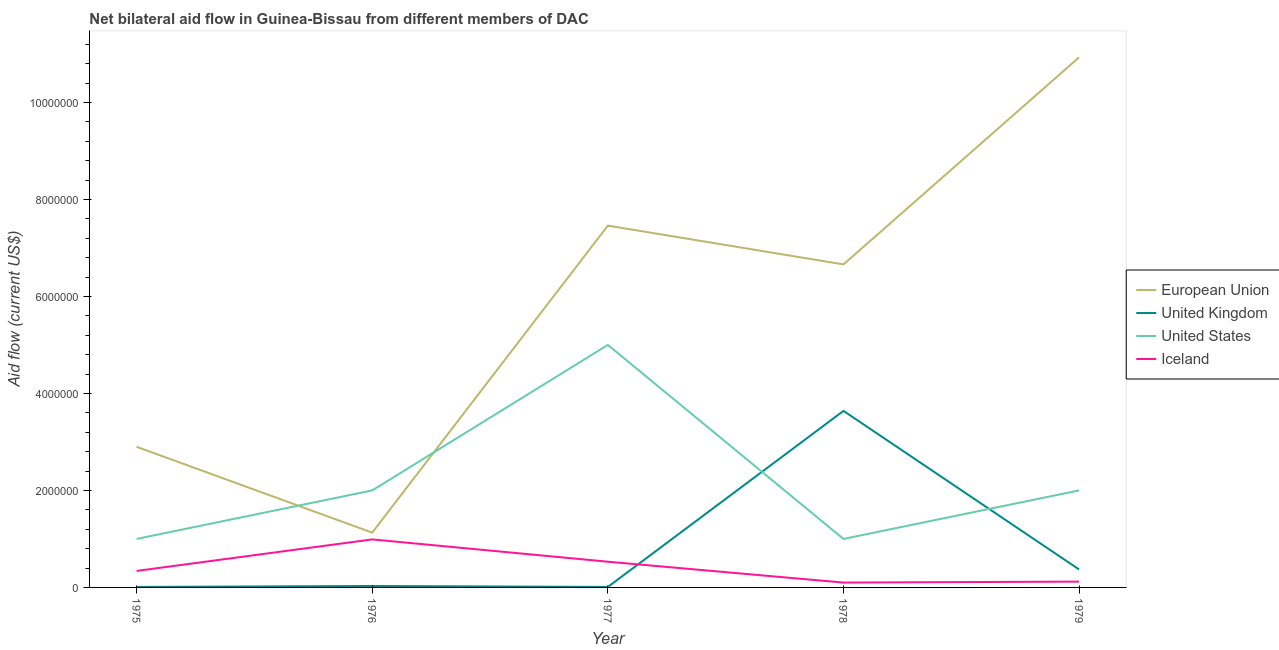Does the line corresponding to amount of aid given by eu intersect with the line corresponding to amount of aid given by uk?
Provide a short and direct response. No. What is the amount of aid given by eu in 1977?
Provide a succinct answer. 7.46e+06. Across all years, what is the maximum amount of aid given by iceland?
Make the answer very short. 9.90e+05. Across all years, what is the minimum amount of aid given by uk?
Offer a very short reply. 10000. In which year was the amount of aid given by us maximum?
Your answer should be very brief. 1977. In which year was the amount of aid given by iceland minimum?
Your answer should be very brief. 1978. What is the total amount of aid given by us in the graph?
Give a very brief answer. 1.10e+07. What is the difference between the amount of aid given by uk in 1975 and that in 1977?
Give a very brief answer. 0. What is the difference between the amount of aid given by iceland in 1979 and the amount of aid given by us in 1976?
Your answer should be very brief. -1.88e+06. What is the average amount of aid given by us per year?
Your answer should be compact. 2.20e+06. In the year 1977, what is the difference between the amount of aid given by eu and amount of aid given by iceland?
Keep it short and to the point. 6.93e+06. In how many years, is the amount of aid given by us greater than 10000000 US$?
Make the answer very short. 0. Is the difference between the amount of aid given by us in 1976 and 1978 greater than the difference between the amount of aid given by iceland in 1976 and 1978?
Your answer should be compact. Yes. What is the difference between the highest and the second highest amount of aid given by us?
Your response must be concise. 3.00e+06. What is the difference between the highest and the lowest amount of aid given by eu?
Provide a short and direct response. 9.80e+06. In how many years, is the amount of aid given by iceland greater than the average amount of aid given by iceland taken over all years?
Your response must be concise. 2. Is it the case that in every year, the sum of the amount of aid given by eu and amount of aid given by uk is greater than the amount of aid given by us?
Ensure brevity in your answer.  No. Does the amount of aid given by uk monotonically increase over the years?
Keep it short and to the point. No. Is the amount of aid given by uk strictly less than the amount of aid given by eu over the years?
Keep it short and to the point. Yes. How many lines are there?
Provide a succinct answer. 4. How many years are there in the graph?
Provide a short and direct response. 5. Are the values on the major ticks of Y-axis written in scientific E-notation?
Your response must be concise. No. Does the graph contain any zero values?
Ensure brevity in your answer.  No. What is the title of the graph?
Provide a short and direct response. Net bilateral aid flow in Guinea-Bissau from different members of DAC. What is the Aid flow (current US$) of European Union in 1975?
Make the answer very short. 2.90e+06. What is the Aid flow (current US$) in Iceland in 1975?
Ensure brevity in your answer.  3.40e+05. What is the Aid flow (current US$) of European Union in 1976?
Ensure brevity in your answer.  1.13e+06. What is the Aid flow (current US$) in United Kingdom in 1976?
Give a very brief answer. 3.00e+04. What is the Aid flow (current US$) in United States in 1976?
Your answer should be compact. 2.00e+06. What is the Aid flow (current US$) in Iceland in 1976?
Your response must be concise. 9.90e+05. What is the Aid flow (current US$) of European Union in 1977?
Your answer should be very brief. 7.46e+06. What is the Aid flow (current US$) of United Kingdom in 1977?
Provide a succinct answer. 10000. What is the Aid flow (current US$) of United States in 1977?
Ensure brevity in your answer.  5.00e+06. What is the Aid flow (current US$) of Iceland in 1977?
Provide a succinct answer. 5.30e+05. What is the Aid flow (current US$) in European Union in 1978?
Your response must be concise. 6.66e+06. What is the Aid flow (current US$) in United Kingdom in 1978?
Offer a very short reply. 3.64e+06. What is the Aid flow (current US$) in Iceland in 1978?
Make the answer very short. 1.00e+05. What is the Aid flow (current US$) in European Union in 1979?
Offer a very short reply. 1.09e+07. What is the Aid flow (current US$) of United Kingdom in 1979?
Give a very brief answer. 3.70e+05. Across all years, what is the maximum Aid flow (current US$) in European Union?
Your answer should be very brief. 1.09e+07. Across all years, what is the maximum Aid flow (current US$) of United Kingdom?
Offer a terse response. 3.64e+06. Across all years, what is the maximum Aid flow (current US$) of United States?
Your answer should be compact. 5.00e+06. Across all years, what is the maximum Aid flow (current US$) of Iceland?
Make the answer very short. 9.90e+05. Across all years, what is the minimum Aid flow (current US$) in European Union?
Your answer should be compact. 1.13e+06. What is the total Aid flow (current US$) in European Union in the graph?
Ensure brevity in your answer.  2.91e+07. What is the total Aid flow (current US$) in United Kingdom in the graph?
Offer a very short reply. 4.06e+06. What is the total Aid flow (current US$) of United States in the graph?
Give a very brief answer. 1.10e+07. What is the total Aid flow (current US$) of Iceland in the graph?
Keep it short and to the point. 2.08e+06. What is the difference between the Aid flow (current US$) in European Union in 1975 and that in 1976?
Offer a terse response. 1.77e+06. What is the difference between the Aid flow (current US$) in United States in 1975 and that in 1976?
Make the answer very short. -1.00e+06. What is the difference between the Aid flow (current US$) of Iceland in 1975 and that in 1976?
Provide a short and direct response. -6.50e+05. What is the difference between the Aid flow (current US$) in European Union in 1975 and that in 1977?
Ensure brevity in your answer.  -4.56e+06. What is the difference between the Aid flow (current US$) in United Kingdom in 1975 and that in 1977?
Your answer should be very brief. 0. What is the difference between the Aid flow (current US$) of United States in 1975 and that in 1977?
Provide a short and direct response. -4.00e+06. What is the difference between the Aid flow (current US$) of Iceland in 1975 and that in 1977?
Offer a terse response. -1.90e+05. What is the difference between the Aid flow (current US$) in European Union in 1975 and that in 1978?
Your answer should be very brief. -3.76e+06. What is the difference between the Aid flow (current US$) in United Kingdom in 1975 and that in 1978?
Your response must be concise. -3.63e+06. What is the difference between the Aid flow (current US$) in United States in 1975 and that in 1978?
Ensure brevity in your answer.  0. What is the difference between the Aid flow (current US$) in Iceland in 1975 and that in 1978?
Give a very brief answer. 2.40e+05. What is the difference between the Aid flow (current US$) in European Union in 1975 and that in 1979?
Keep it short and to the point. -8.03e+06. What is the difference between the Aid flow (current US$) in United Kingdom in 1975 and that in 1979?
Offer a very short reply. -3.60e+05. What is the difference between the Aid flow (current US$) in United States in 1975 and that in 1979?
Provide a succinct answer. -1.00e+06. What is the difference between the Aid flow (current US$) of Iceland in 1975 and that in 1979?
Your answer should be compact. 2.20e+05. What is the difference between the Aid flow (current US$) in European Union in 1976 and that in 1977?
Your answer should be compact. -6.33e+06. What is the difference between the Aid flow (current US$) of European Union in 1976 and that in 1978?
Offer a terse response. -5.53e+06. What is the difference between the Aid flow (current US$) in United Kingdom in 1976 and that in 1978?
Ensure brevity in your answer.  -3.61e+06. What is the difference between the Aid flow (current US$) in Iceland in 1976 and that in 1978?
Keep it short and to the point. 8.90e+05. What is the difference between the Aid flow (current US$) in European Union in 1976 and that in 1979?
Your answer should be compact. -9.80e+06. What is the difference between the Aid flow (current US$) in United States in 1976 and that in 1979?
Your response must be concise. 0. What is the difference between the Aid flow (current US$) of Iceland in 1976 and that in 1979?
Offer a terse response. 8.70e+05. What is the difference between the Aid flow (current US$) of European Union in 1977 and that in 1978?
Keep it short and to the point. 8.00e+05. What is the difference between the Aid flow (current US$) of United Kingdom in 1977 and that in 1978?
Make the answer very short. -3.63e+06. What is the difference between the Aid flow (current US$) of United States in 1977 and that in 1978?
Your response must be concise. 4.00e+06. What is the difference between the Aid flow (current US$) of European Union in 1977 and that in 1979?
Offer a terse response. -3.47e+06. What is the difference between the Aid flow (current US$) in United Kingdom in 1977 and that in 1979?
Your answer should be compact. -3.60e+05. What is the difference between the Aid flow (current US$) of United States in 1977 and that in 1979?
Keep it short and to the point. 3.00e+06. What is the difference between the Aid flow (current US$) of Iceland in 1977 and that in 1979?
Offer a terse response. 4.10e+05. What is the difference between the Aid flow (current US$) in European Union in 1978 and that in 1979?
Provide a short and direct response. -4.27e+06. What is the difference between the Aid flow (current US$) in United Kingdom in 1978 and that in 1979?
Provide a short and direct response. 3.27e+06. What is the difference between the Aid flow (current US$) of United States in 1978 and that in 1979?
Your answer should be very brief. -1.00e+06. What is the difference between the Aid flow (current US$) in Iceland in 1978 and that in 1979?
Your answer should be compact. -2.00e+04. What is the difference between the Aid flow (current US$) in European Union in 1975 and the Aid flow (current US$) in United Kingdom in 1976?
Offer a terse response. 2.87e+06. What is the difference between the Aid flow (current US$) of European Union in 1975 and the Aid flow (current US$) of Iceland in 1976?
Keep it short and to the point. 1.91e+06. What is the difference between the Aid flow (current US$) in United Kingdom in 1975 and the Aid flow (current US$) in United States in 1976?
Provide a short and direct response. -1.99e+06. What is the difference between the Aid flow (current US$) in United Kingdom in 1975 and the Aid flow (current US$) in Iceland in 1976?
Provide a short and direct response. -9.80e+05. What is the difference between the Aid flow (current US$) in European Union in 1975 and the Aid flow (current US$) in United Kingdom in 1977?
Make the answer very short. 2.89e+06. What is the difference between the Aid flow (current US$) of European Union in 1975 and the Aid flow (current US$) of United States in 1977?
Give a very brief answer. -2.10e+06. What is the difference between the Aid flow (current US$) in European Union in 1975 and the Aid flow (current US$) in Iceland in 1977?
Keep it short and to the point. 2.37e+06. What is the difference between the Aid flow (current US$) of United Kingdom in 1975 and the Aid flow (current US$) of United States in 1977?
Ensure brevity in your answer.  -4.99e+06. What is the difference between the Aid flow (current US$) in United Kingdom in 1975 and the Aid flow (current US$) in Iceland in 1977?
Provide a short and direct response. -5.20e+05. What is the difference between the Aid flow (current US$) of European Union in 1975 and the Aid flow (current US$) of United Kingdom in 1978?
Ensure brevity in your answer.  -7.40e+05. What is the difference between the Aid flow (current US$) in European Union in 1975 and the Aid flow (current US$) in United States in 1978?
Offer a very short reply. 1.90e+06. What is the difference between the Aid flow (current US$) in European Union in 1975 and the Aid flow (current US$) in Iceland in 1978?
Provide a short and direct response. 2.80e+06. What is the difference between the Aid flow (current US$) in United Kingdom in 1975 and the Aid flow (current US$) in United States in 1978?
Ensure brevity in your answer.  -9.90e+05. What is the difference between the Aid flow (current US$) in United States in 1975 and the Aid flow (current US$) in Iceland in 1978?
Provide a succinct answer. 9.00e+05. What is the difference between the Aid flow (current US$) in European Union in 1975 and the Aid flow (current US$) in United Kingdom in 1979?
Offer a terse response. 2.53e+06. What is the difference between the Aid flow (current US$) in European Union in 1975 and the Aid flow (current US$) in Iceland in 1979?
Provide a succinct answer. 2.78e+06. What is the difference between the Aid flow (current US$) of United Kingdom in 1975 and the Aid flow (current US$) of United States in 1979?
Provide a short and direct response. -1.99e+06. What is the difference between the Aid flow (current US$) in United Kingdom in 1975 and the Aid flow (current US$) in Iceland in 1979?
Give a very brief answer. -1.10e+05. What is the difference between the Aid flow (current US$) of United States in 1975 and the Aid flow (current US$) of Iceland in 1979?
Your answer should be very brief. 8.80e+05. What is the difference between the Aid flow (current US$) of European Union in 1976 and the Aid flow (current US$) of United Kingdom in 1977?
Make the answer very short. 1.12e+06. What is the difference between the Aid flow (current US$) in European Union in 1976 and the Aid flow (current US$) in United States in 1977?
Ensure brevity in your answer.  -3.87e+06. What is the difference between the Aid flow (current US$) of United Kingdom in 1976 and the Aid flow (current US$) of United States in 1977?
Provide a short and direct response. -4.97e+06. What is the difference between the Aid flow (current US$) of United Kingdom in 1976 and the Aid flow (current US$) of Iceland in 1977?
Provide a short and direct response. -5.00e+05. What is the difference between the Aid flow (current US$) of United States in 1976 and the Aid flow (current US$) of Iceland in 1977?
Keep it short and to the point. 1.47e+06. What is the difference between the Aid flow (current US$) of European Union in 1976 and the Aid flow (current US$) of United Kingdom in 1978?
Offer a very short reply. -2.51e+06. What is the difference between the Aid flow (current US$) of European Union in 1976 and the Aid flow (current US$) of United States in 1978?
Ensure brevity in your answer.  1.30e+05. What is the difference between the Aid flow (current US$) in European Union in 1976 and the Aid flow (current US$) in Iceland in 1978?
Offer a terse response. 1.03e+06. What is the difference between the Aid flow (current US$) of United Kingdom in 1976 and the Aid flow (current US$) of United States in 1978?
Your response must be concise. -9.70e+05. What is the difference between the Aid flow (current US$) in United Kingdom in 1976 and the Aid flow (current US$) in Iceland in 1978?
Ensure brevity in your answer.  -7.00e+04. What is the difference between the Aid flow (current US$) in United States in 1976 and the Aid flow (current US$) in Iceland in 1978?
Offer a very short reply. 1.90e+06. What is the difference between the Aid flow (current US$) in European Union in 1976 and the Aid flow (current US$) in United Kingdom in 1979?
Offer a terse response. 7.60e+05. What is the difference between the Aid flow (current US$) of European Union in 1976 and the Aid flow (current US$) of United States in 1979?
Your answer should be very brief. -8.70e+05. What is the difference between the Aid flow (current US$) of European Union in 1976 and the Aid flow (current US$) of Iceland in 1979?
Give a very brief answer. 1.01e+06. What is the difference between the Aid flow (current US$) in United Kingdom in 1976 and the Aid flow (current US$) in United States in 1979?
Provide a short and direct response. -1.97e+06. What is the difference between the Aid flow (current US$) in United Kingdom in 1976 and the Aid flow (current US$) in Iceland in 1979?
Offer a very short reply. -9.00e+04. What is the difference between the Aid flow (current US$) of United States in 1976 and the Aid flow (current US$) of Iceland in 1979?
Provide a short and direct response. 1.88e+06. What is the difference between the Aid flow (current US$) of European Union in 1977 and the Aid flow (current US$) of United Kingdom in 1978?
Provide a succinct answer. 3.82e+06. What is the difference between the Aid flow (current US$) in European Union in 1977 and the Aid flow (current US$) in United States in 1978?
Provide a succinct answer. 6.46e+06. What is the difference between the Aid flow (current US$) of European Union in 1977 and the Aid flow (current US$) of Iceland in 1978?
Offer a terse response. 7.36e+06. What is the difference between the Aid flow (current US$) of United Kingdom in 1977 and the Aid flow (current US$) of United States in 1978?
Keep it short and to the point. -9.90e+05. What is the difference between the Aid flow (current US$) in United States in 1977 and the Aid flow (current US$) in Iceland in 1978?
Provide a short and direct response. 4.90e+06. What is the difference between the Aid flow (current US$) of European Union in 1977 and the Aid flow (current US$) of United Kingdom in 1979?
Your answer should be compact. 7.09e+06. What is the difference between the Aid flow (current US$) in European Union in 1977 and the Aid flow (current US$) in United States in 1979?
Make the answer very short. 5.46e+06. What is the difference between the Aid flow (current US$) of European Union in 1977 and the Aid flow (current US$) of Iceland in 1979?
Give a very brief answer. 7.34e+06. What is the difference between the Aid flow (current US$) in United Kingdom in 1977 and the Aid flow (current US$) in United States in 1979?
Provide a short and direct response. -1.99e+06. What is the difference between the Aid flow (current US$) in United Kingdom in 1977 and the Aid flow (current US$) in Iceland in 1979?
Provide a short and direct response. -1.10e+05. What is the difference between the Aid flow (current US$) in United States in 1977 and the Aid flow (current US$) in Iceland in 1979?
Keep it short and to the point. 4.88e+06. What is the difference between the Aid flow (current US$) of European Union in 1978 and the Aid flow (current US$) of United Kingdom in 1979?
Ensure brevity in your answer.  6.29e+06. What is the difference between the Aid flow (current US$) of European Union in 1978 and the Aid flow (current US$) of United States in 1979?
Your answer should be compact. 4.66e+06. What is the difference between the Aid flow (current US$) in European Union in 1978 and the Aid flow (current US$) in Iceland in 1979?
Ensure brevity in your answer.  6.54e+06. What is the difference between the Aid flow (current US$) of United Kingdom in 1978 and the Aid flow (current US$) of United States in 1979?
Your answer should be compact. 1.64e+06. What is the difference between the Aid flow (current US$) in United Kingdom in 1978 and the Aid flow (current US$) in Iceland in 1979?
Your answer should be compact. 3.52e+06. What is the difference between the Aid flow (current US$) in United States in 1978 and the Aid flow (current US$) in Iceland in 1979?
Provide a short and direct response. 8.80e+05. What is the average Aid flow (current US$) in European Union per year?
Give a very brief answer. 5.82e+06. What is the average Aid flow (current US$) in United Kingdom per year?
Give a very brief answer. 8.12e+05. What is the average Aid flow (current US$) of United States per year?
Offer a terse response. 2.20e+06. What is the average Aid flow (current US$) in Iceland per year?
Give a very brief answer. 4.16e+05. In the year 1975, what is the difference between the Aid flow (current US$) in European Union and Aid flow (current US$) in United Kingdom?
Offer a very short reply. 2.89e+06. In the year 1975, what is the difference between the Aid flow (current US$) of European Union and Aid flow (current US$) of United States?
Offer a terse response. 1.90e+06. In the year 1975, what is the difference between the Aid flow (current US$) of European Union and Aid flow (current US$) of Iceland?
Keep it short and to the point. 2.56e+06. In the year 1975, what is the difference between the Aid flow (current US$) of United Kingdom and Aid flow (current US$) of United States?
Provide a succinct answer. -9.90e+05. In the year 1975, what is the difference between the Aid flow (current US$) in United Kingdom and Aid flow (current US$) in Iceland?
Give a very brief answer. -3.30e+05. In the year 1975, what is the difference between the Aid flow (current US$) in United States and Aid flow (current US$) in Iceland?
Your response must be concise. 6.60e+05. In the year 1976, what is the difference between the Aid flow (current US$) of European Union and Aid flow (current US$) of United Kingdom?
Your response must be concise. 1.10e+06. In the year 1976, what is the difference between the Aid flow (current US$) in European Union and Aid flow (current US$) in United States?
Make the answer very short. -8.70e+05. In the year 1976, what is the difference between the Aid flow (current US$) in United Kingdom and Aid flow (current US$) in United States?
Your response must be concise. -1.97e+06. In the year 1976, what is the difference between the Aid flow (current US$) in United Kingdom and Aid flow (current US$) in Iceland?
Keep it short and to the point. -9.60e+05. In the year 1976, what is the difference between the Aid flow (current US$) in United States and Aid flow (current US$) in Iceland?
Provide a short and direct response. 1.01e+06. In the year 1977, what is the difference between the Aid flow (current US$) in European Union and Aid flow (current US$) in United Kingdom?
Your answer should be very brief. 7.45e+06. In the year 1977, what is the difference between the Aid flow (current US$) of European Union and Aid flow (current US$) of United States?
Ensure brevity in your answer.  2.46e+06. In the year 1977, what is the difference between the Aid flow (current US$) of European Union and Aid flow (current US$) of Iceland?
Your answer should be very brief. 6.93e+06. In the year 1977, what is the difference between the Aid flow (current US$) in United Kingdom and Aid flow (current US$) in United States?
Ensure brevity in your answer.  -4.99e+06. In the year 1977, what is the difference between the Aid flow (current US$) of United Kingdom and Aid flow (current US$) of Iceland?
Offer a terse response. -5.20e+05. In the year 1977, what is the difference between the Aid flow (current US$) of United States and Aid flow (current US$) of Iceland?
Ensure brevity in your answer.  4.47e+06. In the year 1978, what is the difference between the Aid flow (current US$) of European Union and Aid flow (current US$) of United Kingdom?
Give a very brief answer. 3.02e+06. In the year 1978, what is the difference between the Aid flow (current US$) in European Union and Aid flow (current US$) in United States?
Offer a terse response. 5.66e+06. In the year 1978, what is the difference between the Aid flow (current US$) of European Union and Aid flow (current US$) of Iceland?
Your answer should be very brief. 6.56e+06. In the year 1978, what is the difference between the Aid flow (current US$) of United Kingdom and Aid flow (current US$) of United States?
Keep it short and to the point. 2.64e+06. In the year 1978, what is the difference between the Aid flow (current US$) in United Kingdom and Aid flow (current US$) in Iceland?
Make the answer very short. 3.54e+06. In the year 1978, what is the difference between the Aid flow (current US$) in United States and Aid flow (current US$) in Iceland?
Your answer should be very brief. 9.00e+05. In the year 1979, what is the difference between the Aid flow (current US$) in European Union and Aid flow (current US$) in United Kingdom?
Ensure brevity in your answer.  1.06e+07. In the year 1979, what is the difference between the Aid flow (current US$) in European Union and Aid flow (current US$) in United States?
Your answer should be compact. 8.93e+06. In the year 1979, what is the difference between the Aid flow (current US$) in European Union and Aid flow (current US$) in Iceland?
Ensure brevity in your answer.  1.08e+07. In the year 1979, what is the difference between the Aid flow (current US$) of United Kingdom and Aid flow (current US$) of United States?
Provide a short and direct response. -1.63e+06. In the year 1979, what is the difference between the Aid flow (current US$) in United Kingdom and Aid flow (current US$) in Iceland?
Provide a short and direct response. 2.50e+05. In the year 1979, what is the difference between the Aid flow (current US$) in United States and Aid flow (current US$) in Iceland?
Your response must be concise. 1.88e+06. What is the ratio of the Aid flow (current US$) in European Union in 1975 to that in 1976?
Offer a terse response. 2.57. What is the ratio of the Aid flow (current US$) in United States in 1975 to that in 1976?
Provide a succinct answer. 0.5. What is the ratio of the Aid flow (current US$) of Iceland in 1975 to that in 1976?
Offer a very short reply. 0.34. What is the ratio of the Aid flow (current US$) of European Union in 1975 to that in 1977?
Ensure brevity in your answer.  0.39. What is the ratio of the Aid flow (current US$) of Iceland in 1975 to that in 1977?
Your answer should be compact. 0.64. What is the ratio of the Aid flow (current US$) of European Union in 1975 to that in 1978?
Your response must be concise. 0.44. What is the ratio of the Aid flow (current US$) in United Kingdom in 1975 to that in 1978?
Your answer should be very brief. 0. What is the ratio of the Aid flow (current US$) of United States in 1975 to that in 1978?
Offer a very short reply. 1. What is the ratio of the Aid flow (current US$) of European Union in 1975 to that in 1979?
Your answer should be compact. 0.27. What is the ratio of the Aid flow (current US$) of United Kingdom in 1975 to that in 1979?
Ensure brevity in your answer.  0.03. What is the ratio of the Aid flow (current US$) in Iceland in 1975 to that in 1979?
Make the answer very short. 2.83. What is the ratio of the Aid flow (current US$) of European Union in 1976 to that in 1977?
Your answer should be compact. 0.15. What is the ratio of the Aid flow (current US$) of United States in 1976 to that in 1977?
Your answer should be compact. 0.4. What is the ratio of the Aid flow (current US$) of Iceland in 1976 to that in 1977?
Provide a succinct answer. 1.87. What is the ratio of the Aid flow (current US$) of European Union in 1976 to that in 1978?
Offer a terse response. 0.17. What is the ratio of the Aid flow (current US$) in United Kingdom in 1976 to that in 1978?
Make the answer very short. 0.01. What is the ratio of the Aid flow (current US$) of Iceland in 1976 to that in 1978?
Make the answer very short. 9.9. What is the ratio of the Aid flow (current US$) in European Union in 1976 to that in 1979?
Give a very brief answer. 0.1. What is the ratio of the Aid flow (current US$) of United Kingdom in 1976 to that in 1979?
Provide a succinct answer. 0.08. What is the ratio of the Aid flow (current US$) of United States in 1976 to that in 1979?
Offer a very short reply. 1. What is the ratio of the Aid flow (current US$) in Iceland in 1976 to that in 1979?
Provide a succinct answer. 8.25. What is the ratio of the Aid flow (current US$) of European Union in 1977 to that in 1978?
Make the answer very short. 1.12. What is the ratio of the Aid flow (current US$) of United Kingdom in 1977 to that in 1978?
Your answer should be compact. 0. What is the ratio of the Aid flow (current US$) in Iceland in 1977 to that in 1978?
Give a very brief answer. 5.3. What is the ratio of the Aid flow (current US$) of European Union in 1977 to that in 1979?
Provide a short and direct response. 0.68. What is the ratio of the Aid flow (current US$) in United Kingdom in 1977 to that in 1979?
Give a very brief answer. 0.03. What is the ratio of the Aid flow (current US$) in Iceland in 1977 to that in 1979?
Give a very brief answer. 4.42. What is the ratio of the Aid flow (current US$) of European Union in 1978 to that in 1979?
Your answer should be very brief. 0.61. What is the ratio of the Aid flow (current US$) in United Kingdom in 1978 to that in 1979?
Make the answer very short. 9.84. What is the ratio of the Aid flow (current US$) in Iceland in 1978 to that in 1979?
Provide a short and direct response. 0.83. What is the difference between the highest and the second highest Aid flow (current US$) in European Union?
Your answer should be very brief. 3.47e+06. What is the difference between the highest and the second highest Aid flow (current US$) of United Kingdom?
Offer a very short reply. 3.27e+06. What is the difference between the highest and the second highest Aid flow (current US$) of Iceland?
Your response must be concise. 4.60e+05. What is the difference between the highest and the lowest Aid flow (current US$) in European Union?
Give a very brief answer. 9.80e+06. What is the difference between the highest and the lowest Aid flow (current US$) of United Kingdom?
Offer a very short reply. 3.63e+06. What is the difference between the highest and the lowest Aid flow (current US$) in Iceland?
Your answer should be very brief. 8.90e+05. 